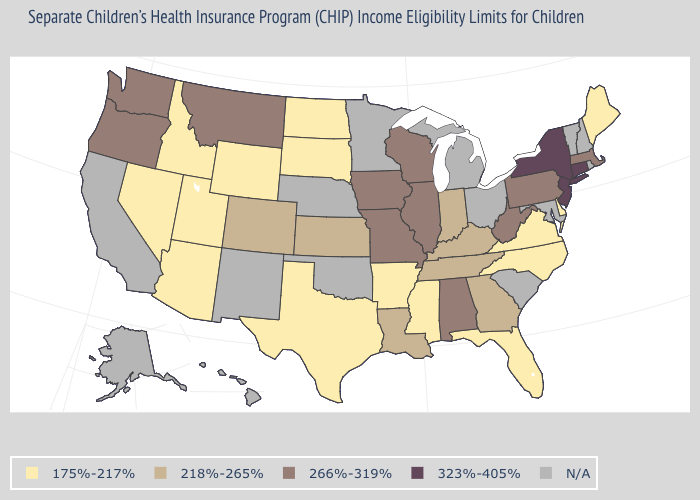Name the states that have a value in the range N/A?
Short answer required. Alaska, California, Hawaii, Maryland, Michigan, Minnesota, Nebraska, New Hampshire, New Mexico, Ohio, Oklahoma, Rhode Island, South Carolina, Vermont. What is the value of Alaska?
Give a very brief answer. N/A. What is the value of Colorado?
Give a very brief answer. 218%-265%. What is the value of Oklahoma?
Answer briefly. N/A. Which states hav the highest value in the MidWest?
Be succinct. Illinois, Iowa, Missouri, Wisconsin. What is the lowest value in states that border Maryland?
Keep it brief. 175%-217%. Which states have the lowest value in the MidWest?
Answer briefly. North Dakota, South Dakota. Name the states that have a value in the range 175%-217%?
Answer briefly. Arizona, Arkansas, Delaware, Florida, Idaho, Maine, Mississippi, Nevada, North Carolina, North Dakota, South Dakota, Texas, Utah, Virginia, Wyoming. Among the states that border Iowa , does South Dakota have the lowest value?
Answer briefly. Yes. What is the lowest value in states that border Ohio?
Concise answer only. 218%-265%. What is the value of Alaska?
Concise answer only. N/A. Name the states that have a value in the range 323%-405%?
Quick response, please. Connecticut, New Jersey, New York. Name the states that have a value in the range 175%-217%?
Short answer required. Arizona, Arkansas, Delaware, Florida, Idaho, Maine, Mississippi, Nevada, North Carolina, North Dakota, South Dakota, Texas, Utah, Virginia, Wyoming. 